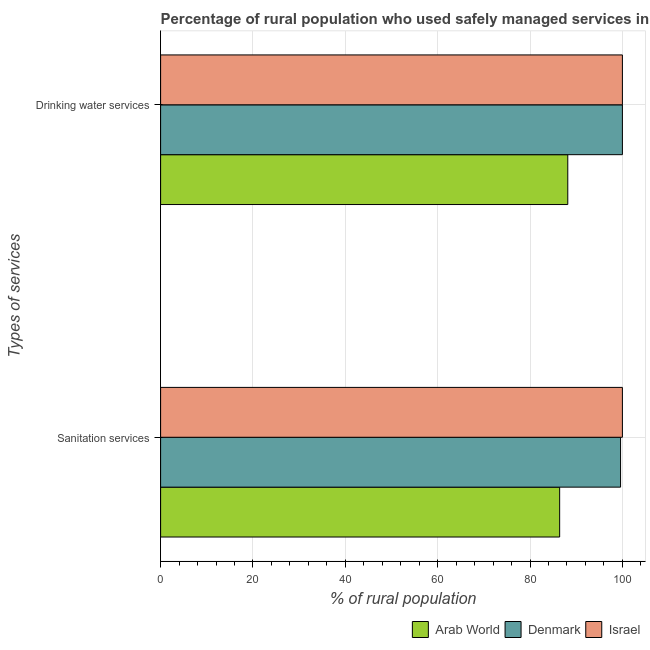How many groups of bars are there?
Ensure brevity in your answer.  2. Are the number of bars per tick equal to the number of legend labels?
Provide a short and direct response. Yes. How many bars are there on the 2nd tick from the top?
Provide a short and direct response. 3. How many bars are there on the 2nd tick from the bottom?
Make the answer very short. 3. What is the label of the 2nd group of bars from the top?
Offer a terse response. Sanitation services. What is the percentage of rural population who used sanitation services in Denmark?
Provide a short and direct response. 99.6. Across all countries, what is the maximum percentage of rural population who used sanitation services?
Your answer should be very brief. 100. Across all countries, what is the minimum percentage of rural population who used drinking water services?
Offer a very short reply. 88.17. In which country was the percentage of rural population who used drinking water services maximum?
Your answer should be compact. Denmark. In which country was the percentage of rural population who used sanitation services minimum?
Give a very brief answer. Arab World. What is the total percentage of rural population who used drinking water services in the graph?
Provide a short and direct response. 288.17. What is the difference between the percentage of rural population who used drinking water services in Arab World and that in Israel?
Make the answer very short. -11.83. What is the difference between the percentage of rural population who used sanitation services in Denmark and the percentage of rural population who used drinking water services in Arab World?
Provide a succinct answer. 11.43. What is the average percentage of rural population who used drinking water services per country?
Ensure brevity in your answer.  96.06. What is the difference between the percentage of rural population who used sanitation services and percentage of rural population who used drinking water services in Arab World?
Make the answer very short. -1.76. In how many countries, is the percentage of rural population who used drinking water services greater than 92 %?
Provide a short and direct response. 2. What is the ratio of the percentage of rural population who used drinking water services in Denmark to that in Israel?
Offer a very short reply. 1. Is the percentage of rural population who used sanitation services in Arab World less than that in Denmark?
Provide a short and direct response. Yes. In how many countries, is the percentage of rural population who used sanitation services greater than the average percentage of rural population who used sanitation services taken over all countries?
Keep it short and to the point. 2. What does the 3rd bar from the top in Drinking water services represents?
Your response must be concise. Arab World. How many bars are there?
Give a very brief answer. 6. Are all the bars in the graph horizontal?
Give a very brief answer. Yes. Are the values on the major ticks of X-axis written in scientific E-notation?
Keep it short and to the point. No. Does the graph contain any zero values?
Provide a short and direct response. No. Does the graph contain grids?
Make the answer very short. Yes. How many legend labels are there?
Make the answer very short. 3. How are the legend labels stacked?
Make the answer very short. Horizontal. What is the title of the graph?
Your response must be concise. Percentage of rural population who used safely managed services in 2015. Does "Guinea" appear as one of the legend labels in the graph?
Provide a short and direct response. No. What is the label or title of the X-axis?
Make the answer very short. % of rural population. What is the label or title of the Y-axis?
Keep it short and to the point. Types of services. What is the % of rural population in Arab World in Sanitation services?
Ensure brevity in your answer.  86.41. What is the % of rural population of Denmark in Sanitation services?
Offer a very short reply. 99.6. What is the % of rural population in Israel in Sanitation services?
Ensure brevity in your answer.  100. What is the % of rural population in Arab World in Drinking water services?
Keep it short and to the point. 88.17. What is the % of rural population of Israel in Drinking water services?
Provide a succinct answer. 100. Across all Types of services, what is the maximum % of rural population of Arab World?
Provide a succinct answer. 88.17. Across all Types of services, what is the maximum % of rural population of Israel?
Keep it short and to the point. 100. Across all Types of services, what is the minimum % of rural population of Arab World?
Provide a short and direct response. 86.41. Across all Types of services, what is the minimum % of rural population of Denmark?
Provide a succinct answer. 99.6. Across all Types of services, what is the minimum % of rural population in Israel?
Your answer should be very brief. 100. What is the total % of rural population of Arab World in the graph?
Ensure brevity in your answer.  174.59. What is the total % of rural population in Denmark in the graph?
Your answer should be very brief. 199.6. What is the total % of rural population of Israel in the graph?
Ensure brevity in your answer.  200. What is the difference between the % of rural population of Arab World in Sanitation services and that in Drinking water services?
Ensure brevity in your answer.  -1.76. What is the difference between the % of rural population in Denmark in Sanitation services and that in Drinking water services?
Provide a short and direct response. -0.4. What is the difference between the % of rural population of Arab World in Sanitation services and the % of rural population of Denmark in Drinking water services?
Offer a very short reply. -13.59. What is the difference between the % of rural population in Arab World in Sanitation services and the % of rural population in Israel in Drinking water services?
Your answer should be compact. -13.59. What is the average % of rural population in Arab World per Types of services?
Offer a very short reply. 87.29. What is the average % of rural population in Denmark per Types of services?
Give a very brief answer. 99.8. What is the average % of rural population in Israel per Types of services?
Provide a succinct answer. 100. What is the difference between the % of rural population in Arab World and % of rural population in Denmark in Sanitation services?
Make the answer very short. -13.19. What is the difference between the % of rural population of Arab World and % of rural population of Israel in Sanitation services?
Provide a short and direct response. -13.59. What is the difference between the % of rural population in Arab World and % of rural population in Denmark in Drinking water services?
Provide a short and direct response. -11.83. What is the difference between the % of rural population of Arab World and % of rural population of Israel in Drinking water services?
Your answer should be compact. -11.83. What is the ratio of the % of rural population of Arab World in Sanitation services to that in Drinking water services?
Keep it short and to the point. 0.98. What is the ratio of the % of rural population in Denmark in Sanitation services to that in Drinking water services?
Offer a very short reply. 1. What is the ratio of the % of rural population in Israel in Sanitation services to that in Drinking water services?
Give a very brief answer. 1. What is the difference between the highest and the second highest % of rural population of Arab World?
Your answer should be compact. 1.76. What is the difference between the highest and the lowest % of rural population in Arab World?
Provide a succinct answer. 1.76. What is the difference between the highest and the lowest % of rural population of Israel?
Your answer should be compact. 0. 